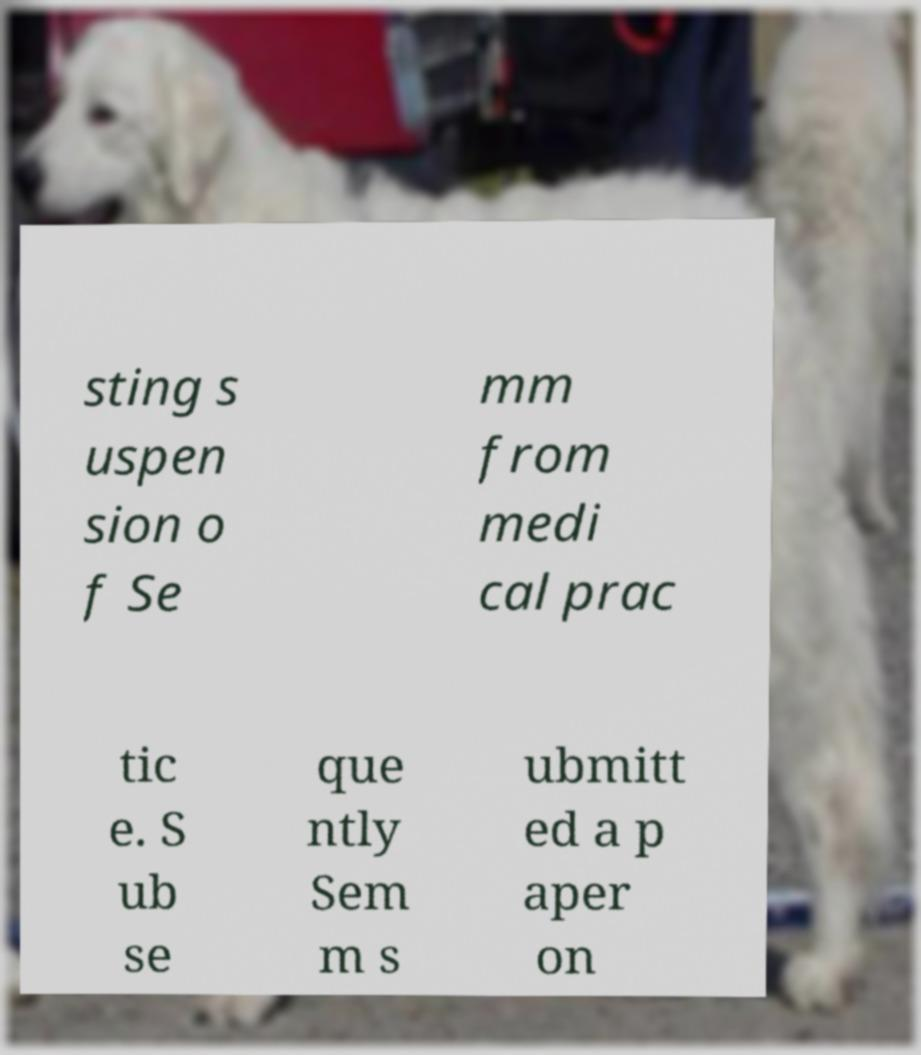There's text embedded in this image that I need extracted. Can you transcribe it verbatim? sting s uspen sion o f Se mm from medi cal prac tic e. S ub se que ntly Sem m s ubmitt ed a p aper on 